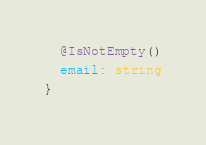<code> <loc_0><loc_0><loc_500><loc_500><_TypeScript_>  @IsNotEmpty()
  email: string
}
</code> 